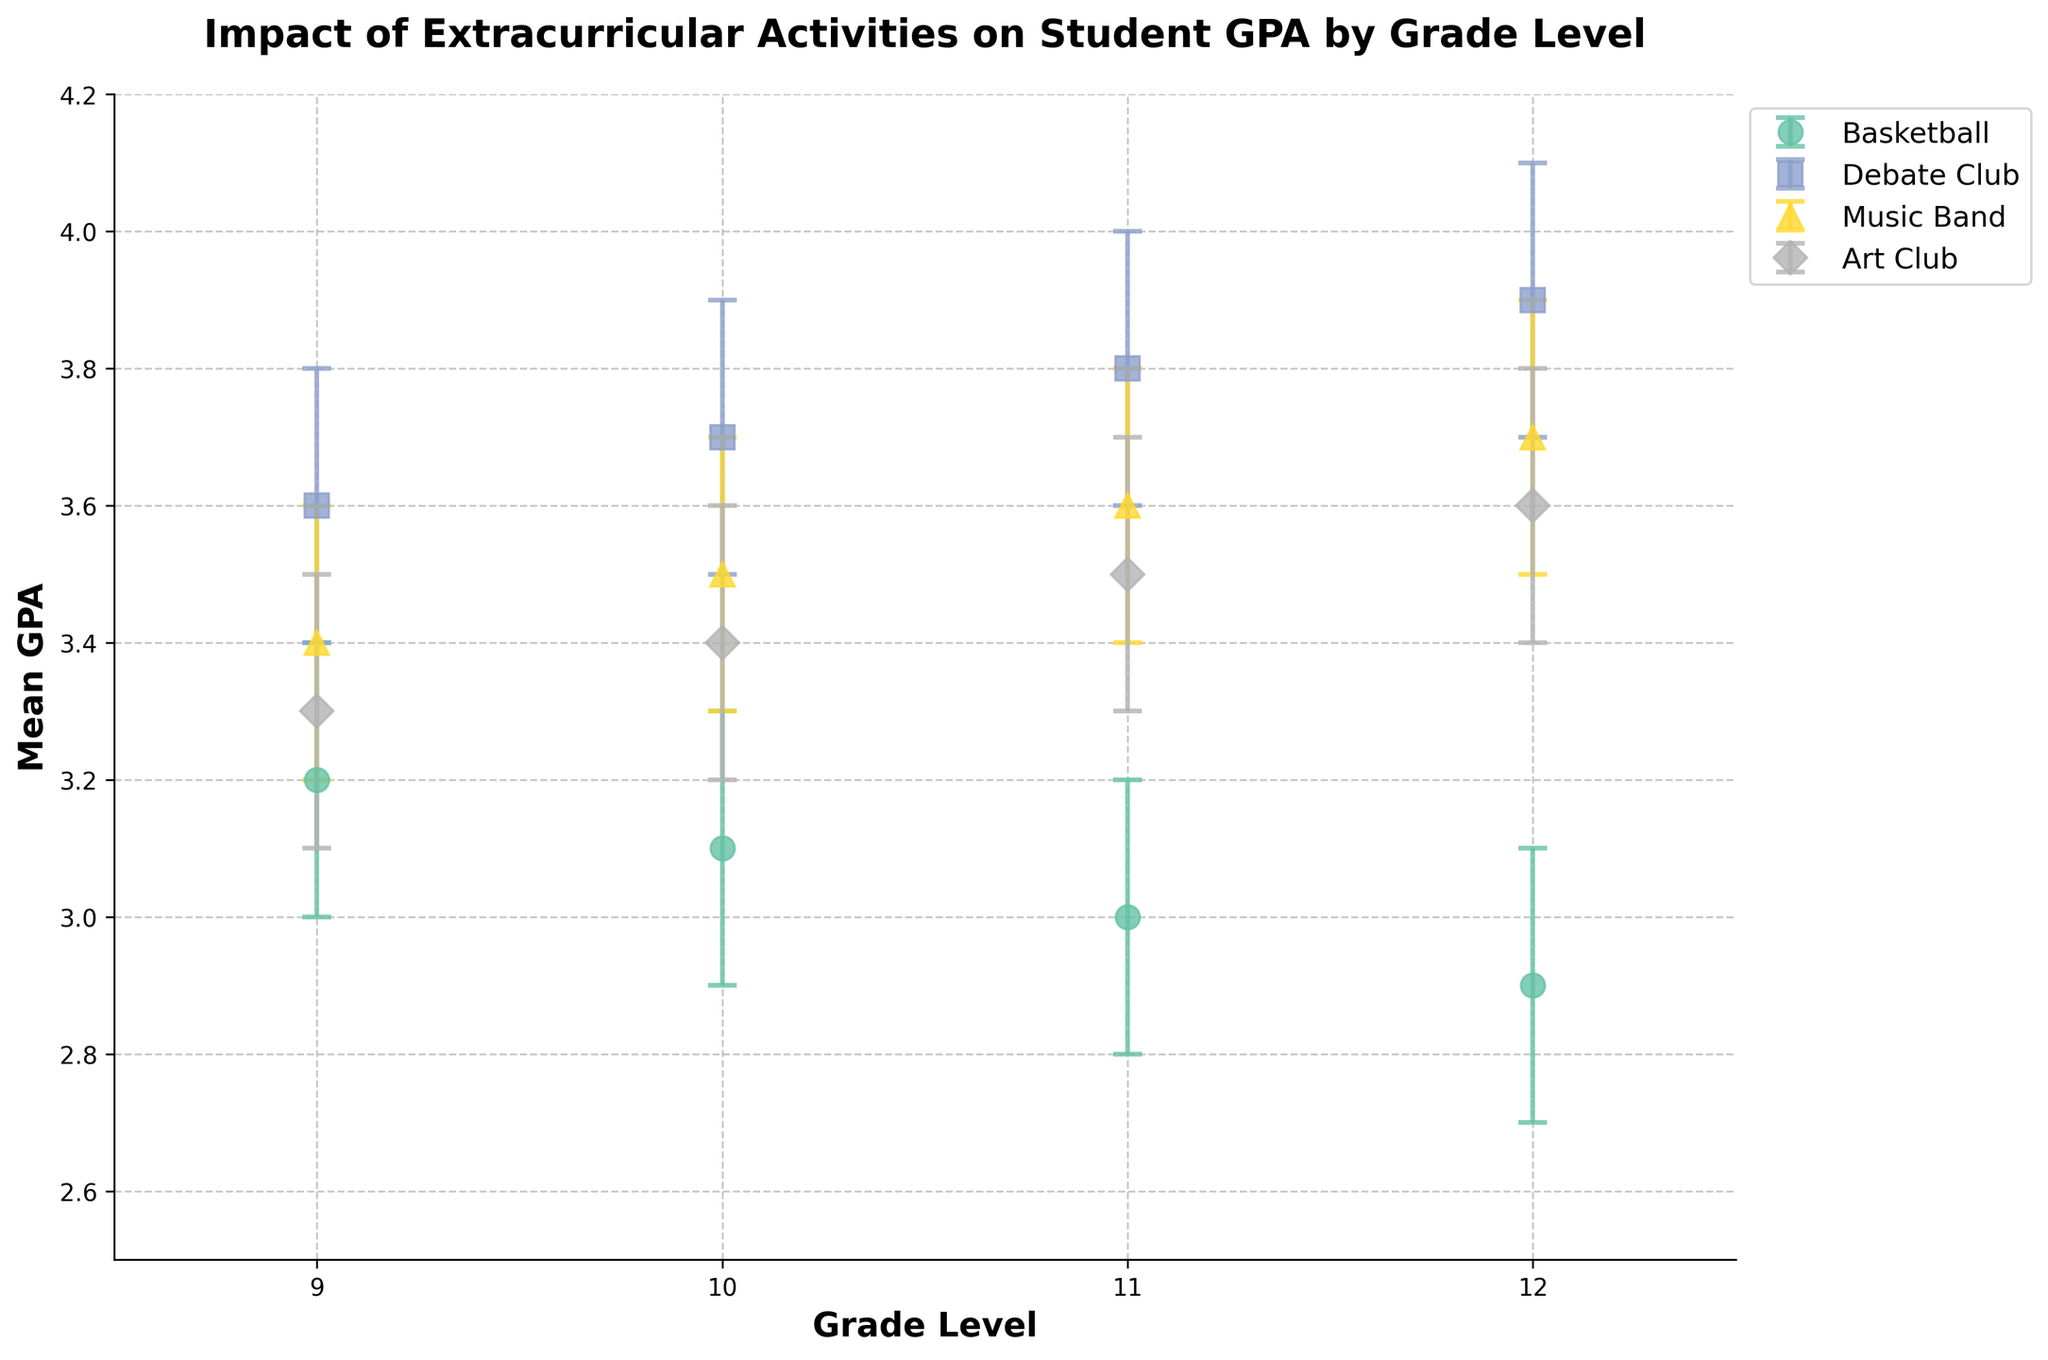What is the title of the figure? The title of the figure is typically displayed at the top of the plot. In this case, the title reads "Impact of Extracurricular Activities on Student GPA by Grade Level".
Answer: Impact of Extracurricular Activities on Student GPA by Grade Level Which extracurricular activity shows the highest mean GPA for 12th-grade students? Look at the data points for 12th grade and identify the one with the highest position on the vertical axis. Debate Club has the highest mean GPA (3.9) for 12th-grade students.
Answer: Debate Club What is the range of the confidence interval for Music Band in 11th grade? Locate the Music Band data point for 11th grade and observe the error bars. The confidence interval for Music Band in 11th grade is from 3.4 to 3.8. The range is the difference between the upper and lower bounds (3.8 - 3.4).
Answer: 0.4 Which grade level shows the lowest mean GPA for Basketball? Look for the data points for Basketball and find the one at the lowest vertical position. The 12th grade shows the lowest mean GPA for Basketball, which is 2.9.
Answer: 12th grade How does the confidence interval width for Debate Club in 9th grade compare to that in 12th grade? For 9th grade, the confidence interval for Debate Club is from 3.4 to 3.8, giving a width of 0.4. For 12th grade, the confidence interval is from 3.7 to 4.1, also giving a width of 0.4. Both intervals have the same width.
Answer: The same Between which activities does the 10th-grade mean GPA differ the most? Identify the mean GPA values for 10th grade across all activities: Basketball (3.1), Debate Club (3.7), Music Band (3.5), and Art Club (3.4). The greatest difference is between Basketball and Debate Club (3.7 - 3.1).
Answer: Basketball and Debate Club At which grade level does the mean GPA for Art Club surpass that of Basketball by the largest margin? Compare the difference between the mean GPA of Art Club and Basketball across all grade levels: 9th grade (3.3 - 3.2), 10th grade (3.4 - 3.1), 11th grade (3.5 - 3.0), and 12th grade (3.6 - 2.9). The largest margin is at 12th grade (3.6 - 2.9 = 0.7).
Answer: 12th grade For which activity and grade level is the mean GPA least precisely estimated? Precision can be interpreted from the width of the confidence interval. Search for the activity-grade combination with the widest confidence interval. Debate Club in 12th grade has an interval from 3.7 to 4.1, width of 0.4, which is matched by other data points, but among these, 12th grade Debate Club stands out with high mean GPA.
Answer: Debate Club in 12th grade 